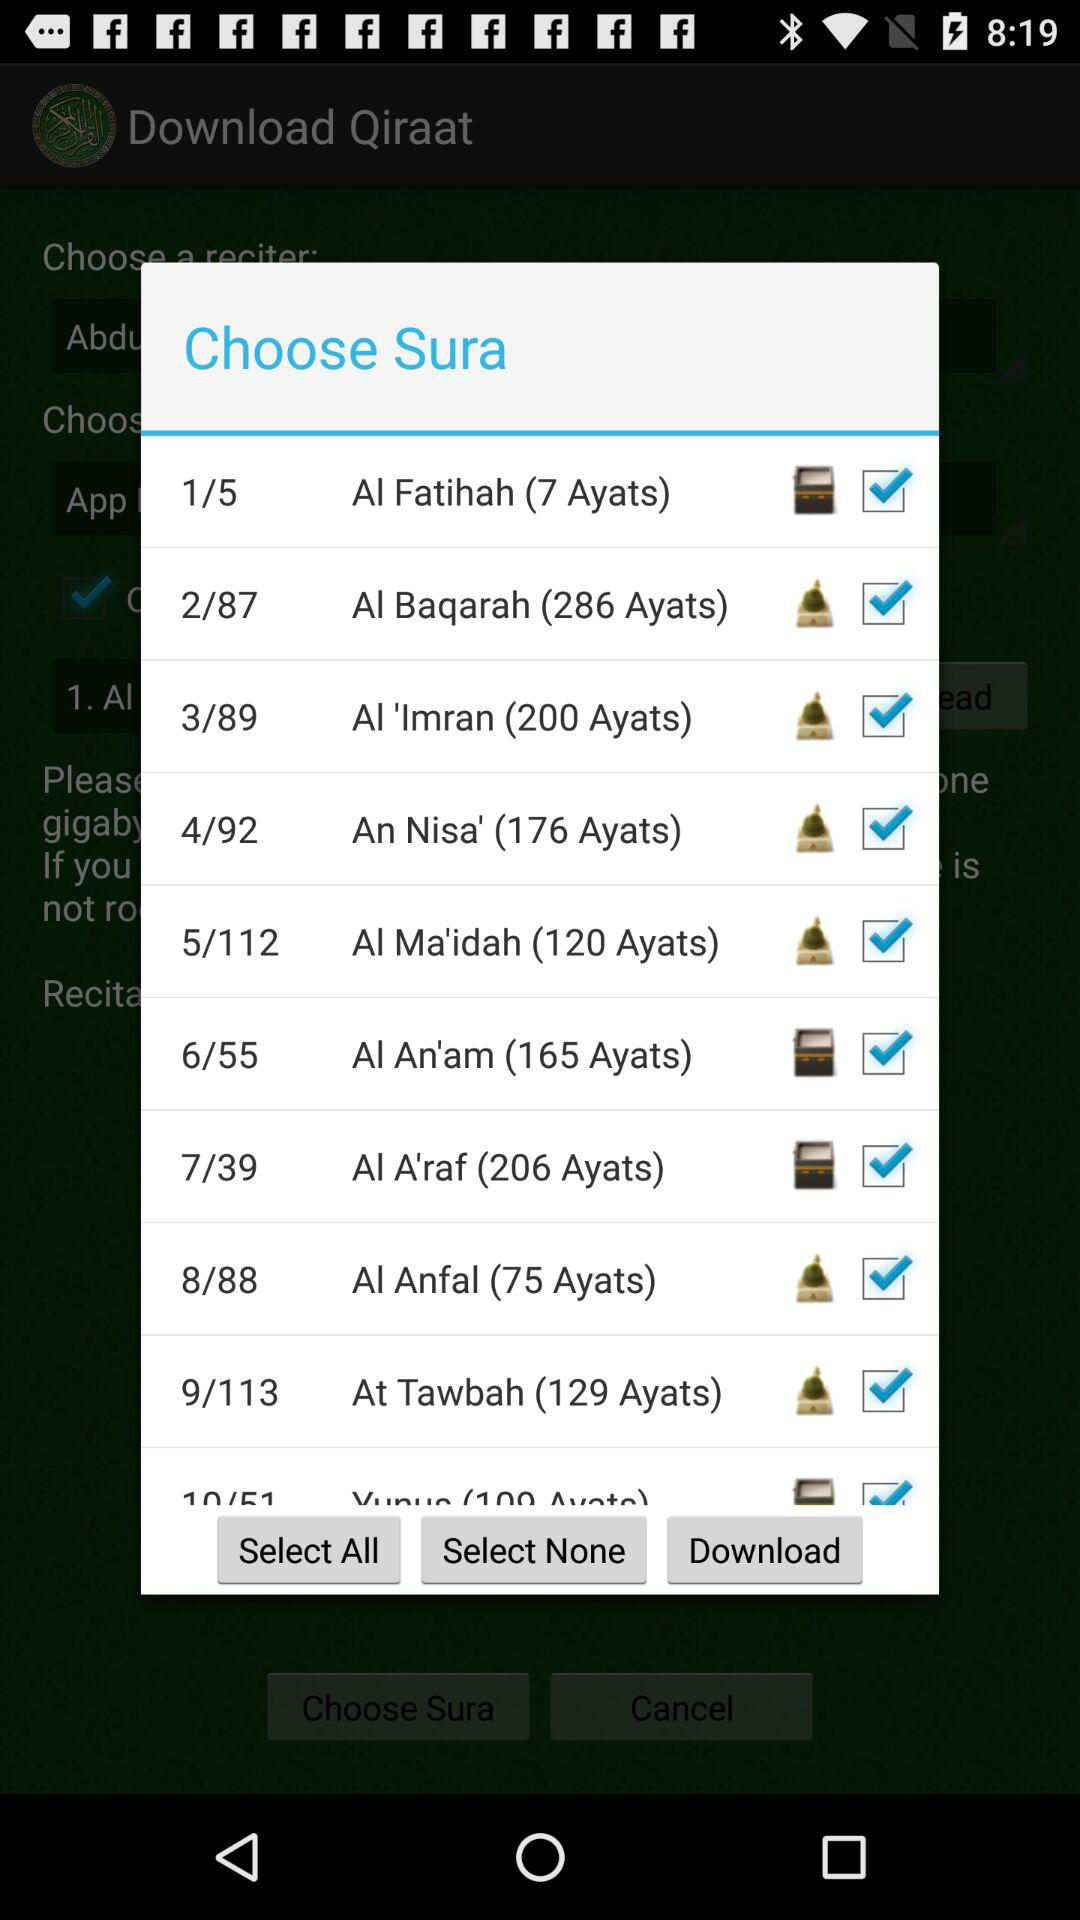What is the name of the sura with the number 5/112? The name of the sura is "Al Ma'idah". 